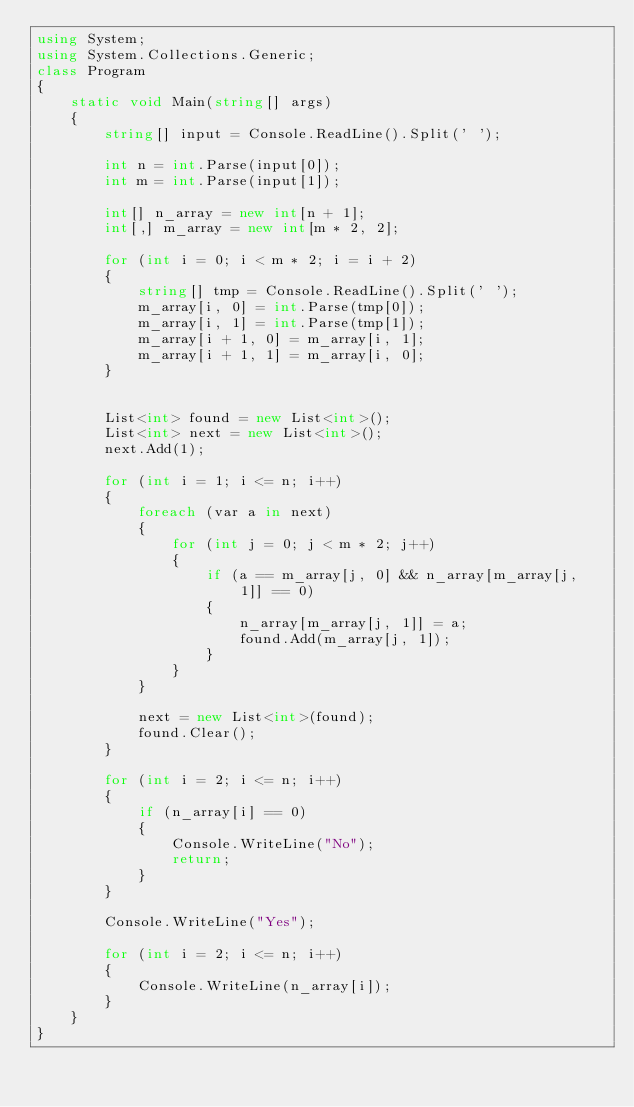<code> <loc_0><loc_0><loc_500><loc_500><_C#_>using System;
using System.Collections.Generic;
class Program
{
    static void Main(string[] args)
    {
        string[] input = Console.ReadLine().Split(' ');

        int n = int.Parse(input[0]);
        int m = int.Parse(input[1]);

        int[] n_array = new int[n + 1];
        int[,] m_array = new int[m * 2, 2];

        for (int i = 0; i < m * 2; i = i + 2)
        {
            string[] tmp = Console.ReadLine().Split(' ');
            m_array[i, 0] = int.Parse(tmp[0]);
            m_array[i, 1] = int.Parse(tmp[1]);
            m_array[i + 1, 0] = m_array[i, 1];
            m_array[i + 1, 1] = m_array[i, 0];
        }


        List<int> found = new List<int>();
        List<int> next = new List<int>();
        next.Add(1);

        for (int i = 1; i <= n; i++)
        {
            foreach (var a in next)
            {
                for (int j = 0; j < m * 2; j++)
                {
                    if (a == m_array[j, 0] && n_array[m_array[j, 1]] == 0)
                    {
                        n_array[m_array[j, 1]] = a;
                        found.Add(m_array[j, 1]);
                    }
                }
            }

            next = new List<int>(found);
            found.Clear();
        }

        for (int i = 2; i <= n; i++)
        {
            if (n_array[i] == 0)
            {
                Console.WriteLine("No");
                return;
            }
        }

        Console.WriteLine("Yes");

        for (int i = 2; i <= n; i++)
        {
            Console.WriteLine(n_array[i]);
        }
    }
}</code> 